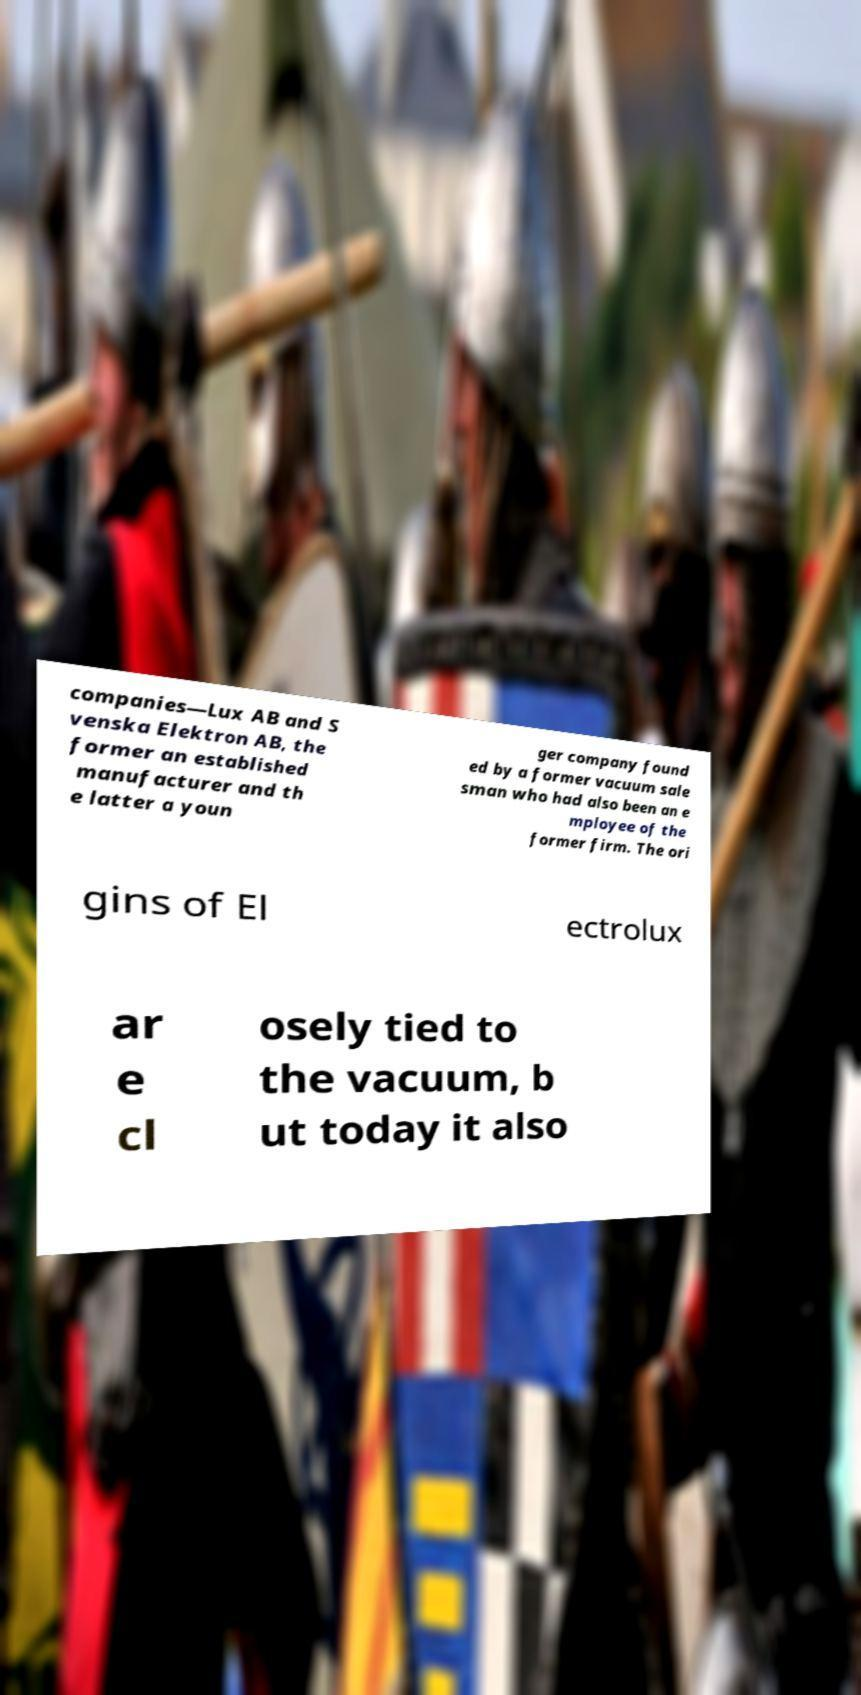What messages or text are displayed in this image? I need them in a readable, typed format. companies—Lux AB and S venska Elektron AB, the former an established manufacturer and th e latter a youn ger company found ed by a former vacuum sale sman who had also been an e mployee of the former firm. The ori gins of El ectrolux ar e cl osely tied to the vacuum, b ut today it also 